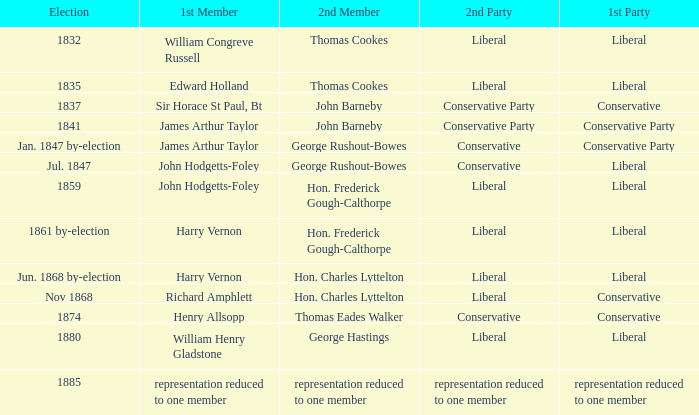What was the other party when its next member was george rushout-bowes, and the primary party was liberal? Conservative. 